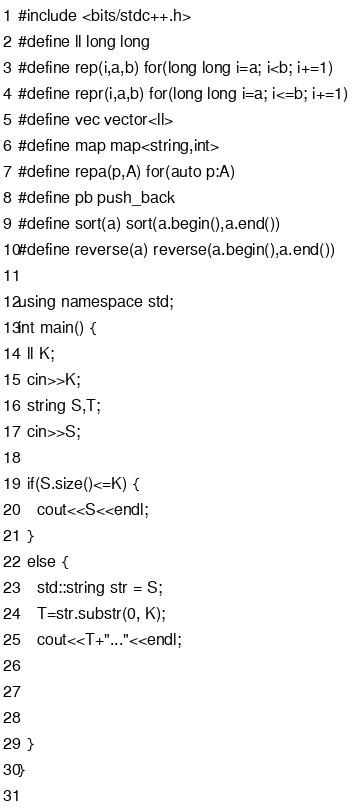<code> <loc_0><loc_0><loc_500><loc_500><_C++_>#include <bits/stdc++.h>
#define ll long long
#define rep(i,a,b) for(long long i=a; i<b; i+=1)
#define repr(i,a,b) for(long long i=a; i<=b; i+=1)
#define vec vector<ll>
#define map map<string,int>
#define repa(p,A) for(auto p:A)
#define pb push_back
#define sort(a) sort(a.begin(),a.end())
#define reverse(a) reverse(a.begin(),a.end())

using namespace std;
int main() {
  ll K;
  cin>>K;
  string S,T;
  cin>>S;
  
  if(S.size()<=K) {
    cout<<S<<endl;
  }
  else {
    std::string str = S;
    T=str.substr(0, K);
    cout<<T+"..."<<endl;
  
     
    
  }
}
    </code> 